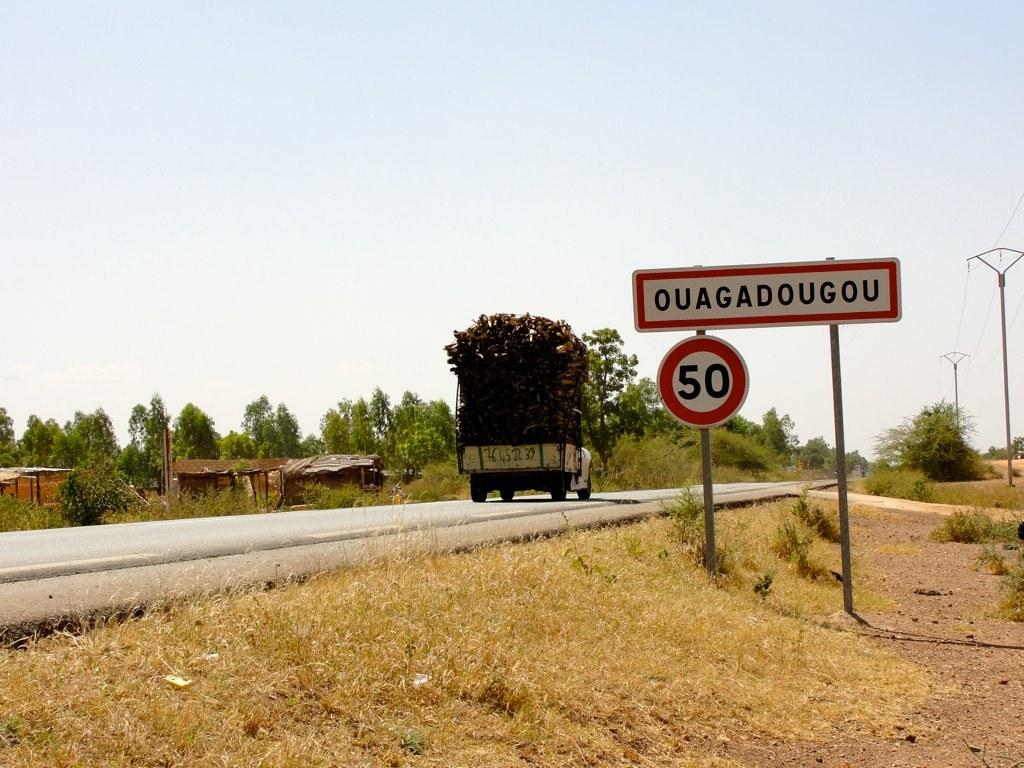<image>
Present a compact description of the photo's key features. A sign for Ouagadougou and the number 50 is displayed on the side of the road. 